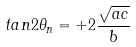Convert formula to latex. <formula><loc_0><loc_0><loc_500><loc_500>t a n 2 \theta _ { n } = + 2 \frac { \sqrt { a c } } { b }</formula> 